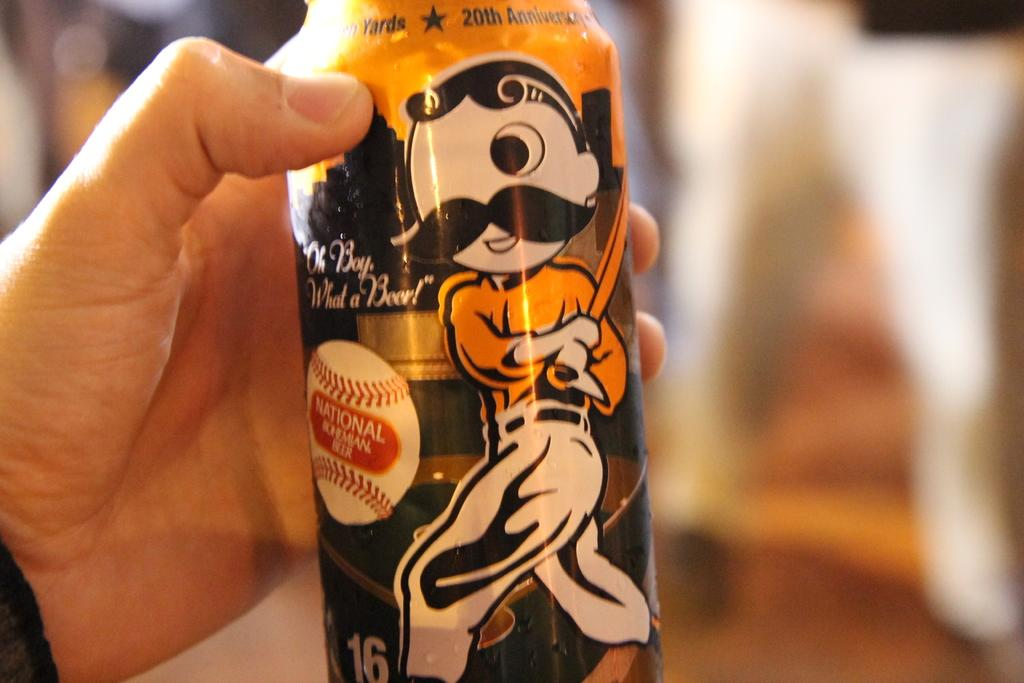<image>
Render a clear and concise summary of the photo. The beer can that is held by a hand has a cartoon figure playing baseball and the words "Oh Boy, What a Beer!" on it. 